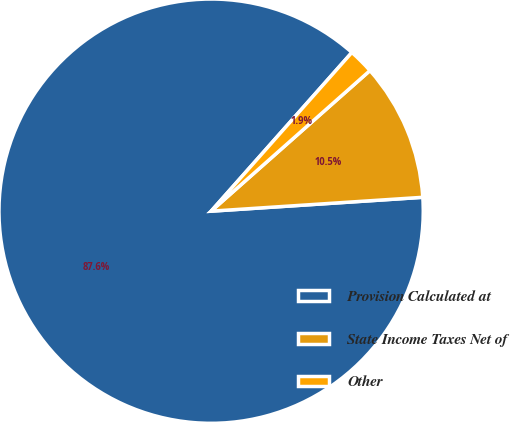Convert chart. <chart><loc_0><loc_0><loc_500><loc_500><pie_chart><fcel>Provision Calculated at<fcel>State Income Taxes Net of<fcel>Other<nl><fcel>87.59%<fcel>10.49%<fcel>1.92%<nl></chart> 